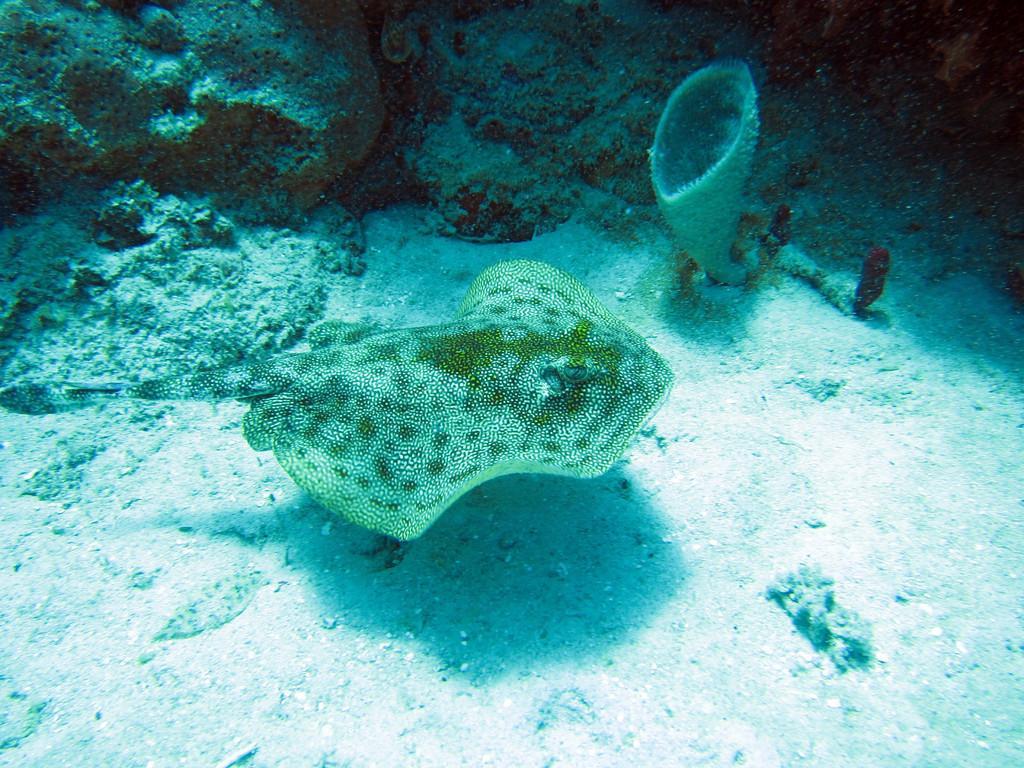Could you give a brief overview of what you see in this image? The picture is taken in the water. In the center of the picture there is raw fish. At the bottom there is sand. At the top, it is coral reef. 